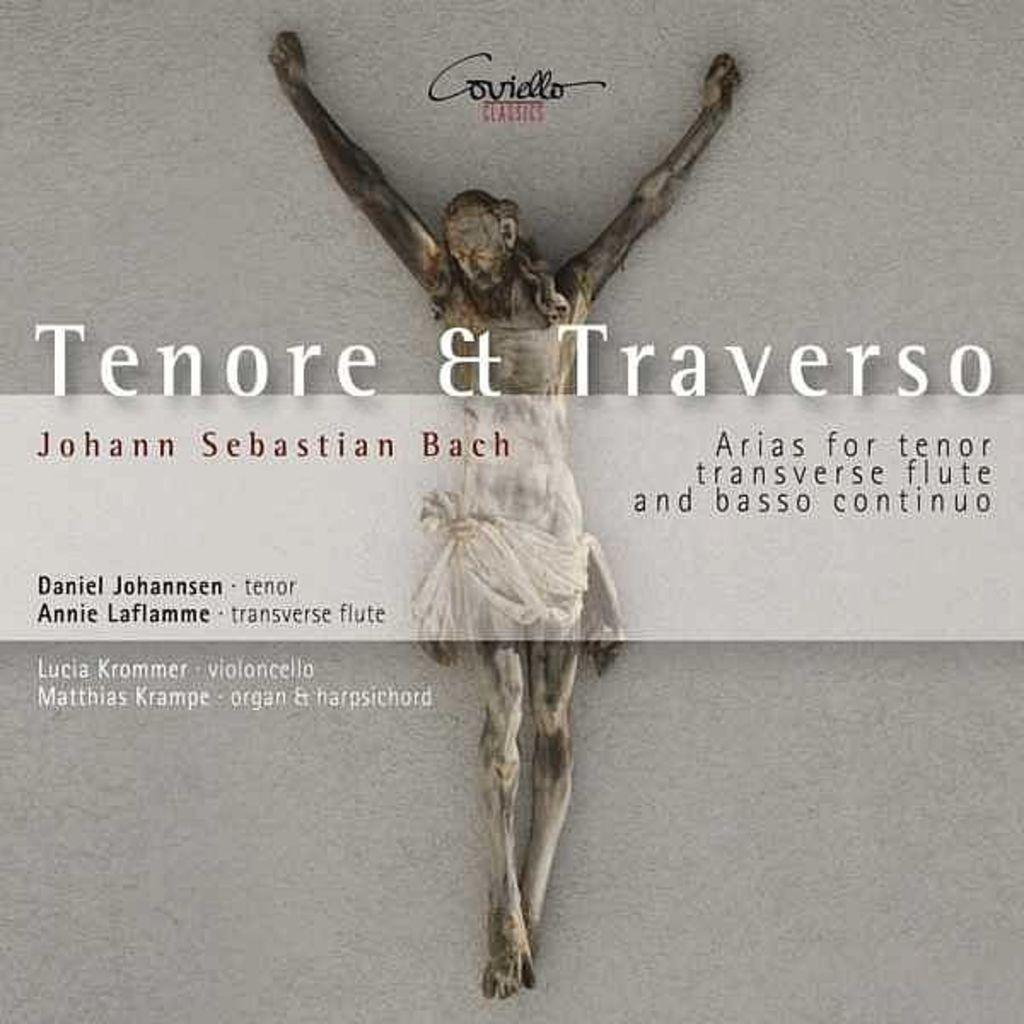What type of visual is the image? The image is a poster. What can be found in the middle of the poster? There is text in the middle of the poster. Is there any text located elsewhere on the poster? Yes, there is text on the top of the poster. Can you describe the person in the image? The person is on a grey surface in the image. What type of cloud is floating above the person in the image? There is no cloud present in the image; it is a poster with text and a person on a grey surface. What force is being exerted on the person in the image? There is no indication of any force being exerted on the person in the image. 